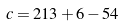<formula> <loc_0><loc_0><loc_500><loc_500>c = 2 1 3 + 6 - 5 4</formula> 